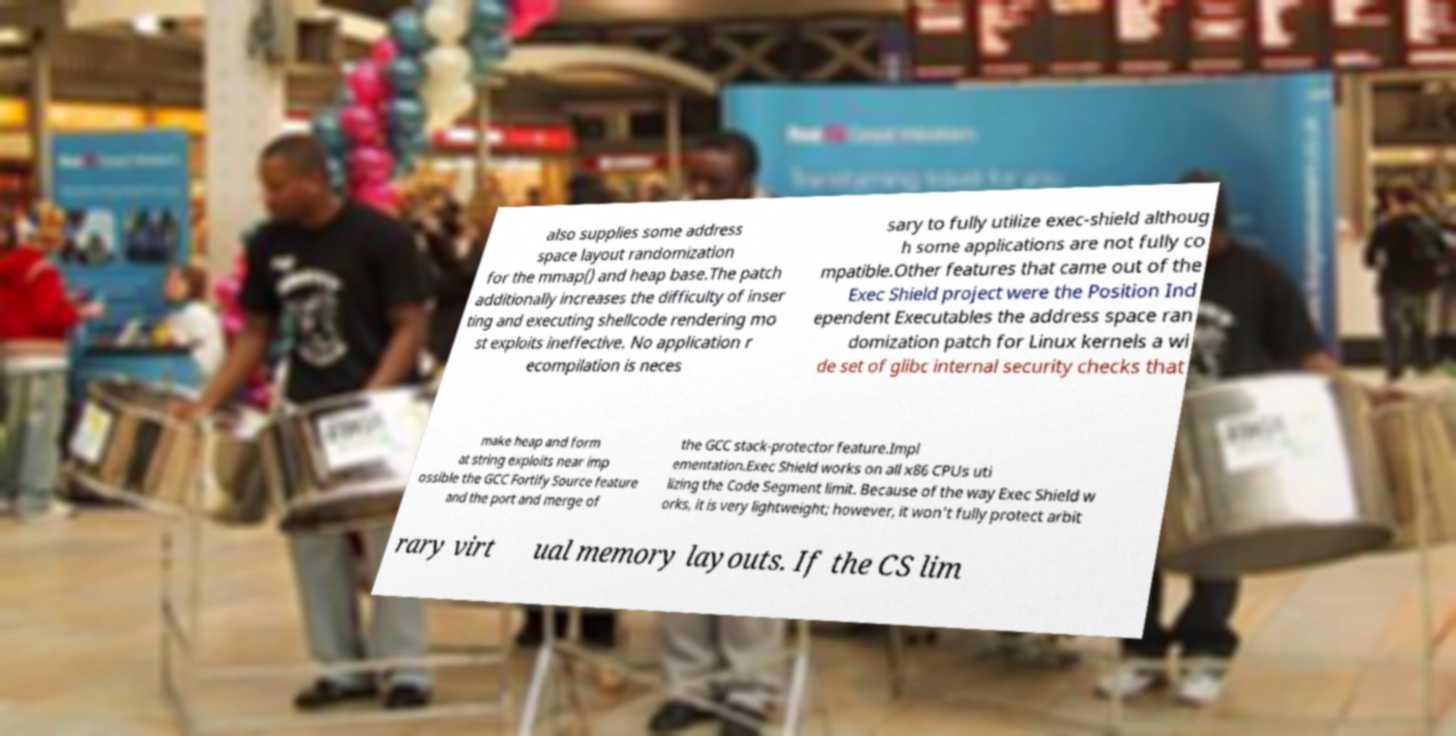Please identify and transcribe the text found in this image. also supplies some address space layout randomization for the mmap() and heap base.The patch additionally increases the difficulty of inser ting and executing shellcode rendering mo st exploits ineffective. No application r ecompilation is neces sary to fully utilize exec-shield althoug h some applications are not fully co mpatible.Other features that came out of the Exec Shield project were the Position Ind ependent Executables the address space ran domization patch for Linux kernels a wi de set of glibc internal security checks that make heap and form at string exploits near imp ossible the GCC Fortify Source feature and the port and merge of the GCC stack-protector feature.Impl ementation.Exec Shield works on all x86 CPUs uti lizing the Code Segment limit. Because of the way Exec Shield w orks, it is very lightweight; however, it won't fully protect arbit rary virt ual memory layouts. If the CS lim 